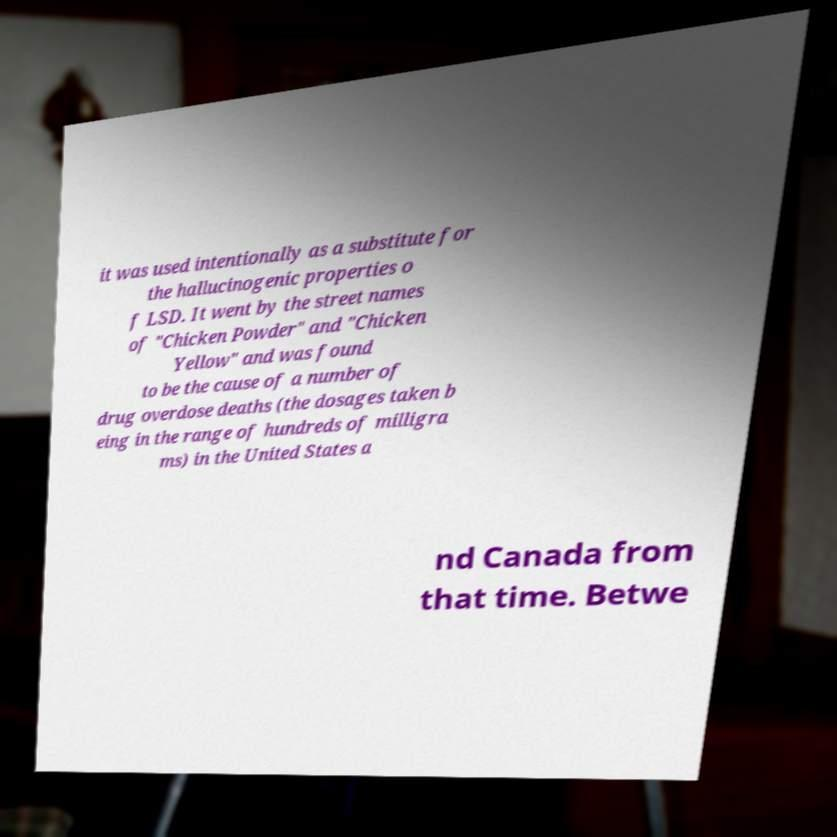What messages or text are displayed in this image? I need them in a readable, typed format. it was used intentionally as a substitute for the hallucinogenic properties o f LSD. It went by the street names of "Chicken Powder" and "Chicken Yellow" and was found to be the cause of a number of drug overdose deaths (the dosages taken b eing in the range of hundreds of milligra ms) in the United States a nd Canada from that time. Betwe 